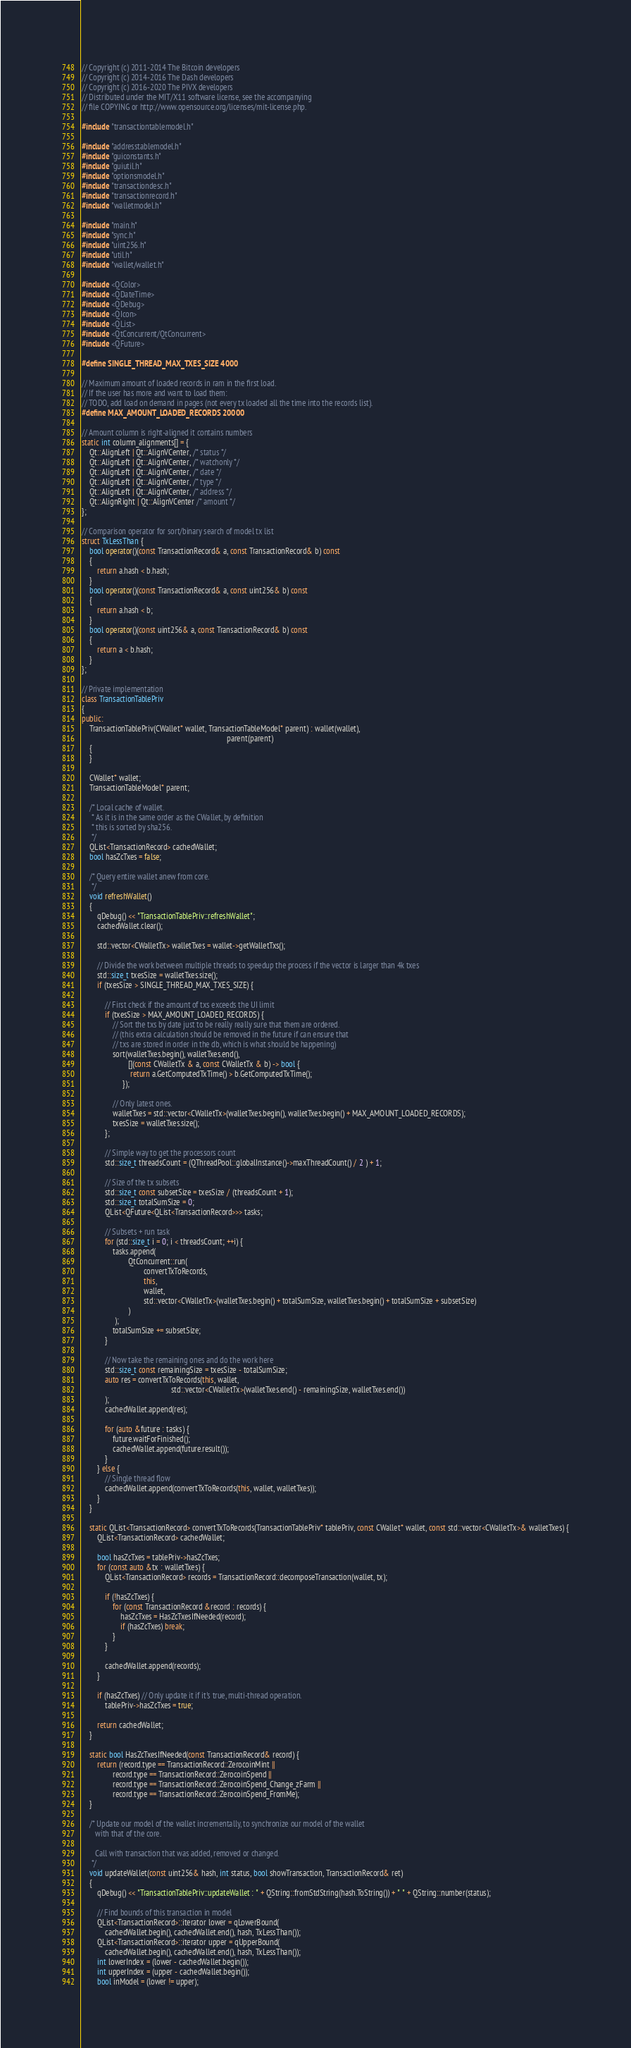<code> <loc_0><loc_0><loc_500><loc_500><_C++_>// Copyright (c) 2011-2014 The Bitcoin developers
// Copyright (c) 2014-2016 The Dash developers
// Copyright (c) 2016-2020 The PIVX developers
// Distributed under the MIT/X11 software license, see the accompanying
// file COPYING or http://www.opensource.org/licenses/mit-license.php.

#include "transactiontablemodel.h"

#include "addresstablemodel.h"
#include "guiconstants.h"
#include "guiutil.h"
#include "optionsmodel.h"
#include "transactiondesc.h"
#include "transactionrecord.h"
#include "walletmodel.h"

#include "main.h"
#include "sync.h"
#include "uint256.h"
#include "util.h"
#include "wallet/wallet.h"

#include <QColor>
#include <QDateTime>
#include <QDebug>
#include <QIcon>
#include <QList>
#include <QtConcurrent/QtConcurrent>
#include <QFuture>

#define SINGLE_THREAD_MAX_TXES_SIZE 4000

// Maximum amount of loaded records in ram in the first load.
// If the user has more and want to load them:
// TODO, add load on demand in pages (not every tx loaded all the time into the records list).
#define MAX_AMOUNT_LOADED_RECORDS 20000

// Amount column is right-aligned it contains numbers
static int column_alignments[] = {
    Qt::AlignLeft | Qt::AlignVCenter, /* status */
    Qt::AlignLeft | Qt::AlignVCenter, /* watchonly */
    Qt::AlignLeft | Qt::AlignVCenter, /* date */
    Qt::AlignLeft | Qt::AlignVCenter, /* type */
    Qt::AlignLeft | Qt::AlignVCenter, /* address */
    Qt::AlignRight | Qt::AlignVCenter /* amount */
};

// Comparison operator for sort/binary search of model tx list
struct TxLessThan {
    bool operator()(const TransactionRecord& a, const TransactionRecord& b) const
    {
        return a.hash < b.hash;
    }
    bool operator()(const TransactionRecord& a, const uint256& b) const
    {
        return a.hash < b;
    }
    bool operator()(const uint256& a, const TransactionRecord& b) const
    {
        return a < b.hash;
    }
};

// Private implementation
class TransactionTablePriv
{
public:
    TransactionTablePriv(CWallet* wallet, TransactionTableModel* parent) : wallet(wallet),
                                                                           parent(parent)
    {
    }

    CWallet* wallet;
    TransactionTableModel* parent;

    /* Local cache of wallet.
     * As it is in the same order as the CWallet, by definition
     * this is sorted by sha256.
     */
    QList<TransactionRecord> cachedWallet;
    bool hasZcTxes = false;

    /* Query entire wallet anew from core.
     */
    void refreshWallet()
    {
        qDebug() << "TransactionTablePriv::refreshWallet";
        cachedWallet.clear();

        std::vector<CWalletTx> walletTxes = wallet->getWalletTxs();

        // Divide the work between multiple threads to speedup the process if the vector is larger than 4k txes
        std::size_t txesSize = walletTxes.size();
        if (txesSize > SINGLE_THREAD_MAX_TXES_SIZE) {

            // First check if the amount of txs exceeds the UI limit
            if (txesSize > MAX_AMOUNT_LOADED_RECORDS) {
                // Sort the txs by date just to be really really sure that them are ordered.
                // (this extra calculation should be removed in the future if can ensure that
                // txs are stored in order in the db, which is what should be happening)
                sort(walletTxes.begin(), walletTxes.end(),
                        [](const CWalletTx & a, const CWalletTx & b) -> bool {
                         return a.GetComputedTxTime() > b.GetComputedTxTime();
                     });

                // Only latest ones.
                walletTxes = std::vector<CWalletTx>(walletTxes.begin(), walletTxes.begin() + MAX_AMOUNT_LOADED_RECORDS);
                txesSize = walletTxes.size();
            };

            // Simple way to get the processors count
            std::size_t threadsCount = (QThreadPool::globalInstance()->maxThreadCount() / 2 ) + 1;

            // Size of the tx subsets
            std::size_t const subsetSize = txesSize / (threadsCount + 1);
            std::size_t totalSumSize = 0;
            QList<QFuture<QList<TransactionRecord>>> tasks;

            // Subsets + run task
            for (std::size_t i = 0; i < threadsCount; ++i) {
                tasks.append(
                        QtConcurrent::run(
                                convertTxToRecords,
                                this,
                                wallet,
                                std::vector<CWalletTx>(walletTxes.begin() + totalSumSize, walletTxes.begin() + totalSumSize + subsetSize)
                        )
                 );
                totalSumSize += subsetSize;
            }

            // Now take the remaining ones and do the work here
            std::size_t const remainingSize = txesSize - totalSumSize;
            auto res = convertTxToRecords(this, wallet,
                                              std::vector<CWalletTx>(walletTxes.end() - remainingSize, walletTxes.end())
            );
            cachedWallet.append(res);

            for (auto &future : tasks) {
                future.waitForFinished();
                cachedWallet.append(future.result());
            }
        } else {
            // Single thread flow
            cachedWallet.append(convertTxToRecords(this, wallet, walletTxes));
        }
    }

    static QList<TransactionRecord> convertTxToRecords(TransactionTablePriv* tablePriv, const CWallet* wallet, const std::vector<CWalletTx>& walletTxes) {
        QList<TransactionRecord> cachedWallet;

        bool hasZcTxes = tablePriv->hasZcTxes;
        for (const auto &tx : walletTxes) {
            QList<TransactionRecord> records = TransactionRecord::decomposeTransaction(wallet, tx);

            if (!hasZcTxes) {
                for (const TransactionRecord &record : records) {
                    hasZcTxes = HasZcTxesIfNeeded(record);
                    if (hasZcTxes) break;
                }
            }

            cachedWallet.append(records);
        }

        if (hasZcTxes) // Only update it if it's true, multi-thread operation.
            tablePriv->hasZcTxes = true;

        return cachedWallet;
    }

    static bool HasZcTxesIfNeeded(const TransactionRecord& record) {
        return (record.type == TransactionRecord::ZerocoinMint ||
                record.type == TransactionRecord::ZerocoinSpend ||
                record.type == TransactionRecord::ZerocoinSpend_Change_zFarm ||
                record.type == TransactionRecord::ZerocoinSpend_FromMe);
    }

    /* Update our model of the wallet incrementally, to synchronize our model of the wallet
       with that of the core.

       Call with transaction that was added, removed or changed.
     */
    void updateWallet(const uint256& hash, int status, bool showTransaction, TransactionRecord& ret)
    {
        qDebug() << "TransactionTablePriv::updateWallet : " + QString::fromStdString(hash.ToString()) + " " + QString::number(status);

        // Find bounds of this transaction in model
        QList<TransactionRecord>::iterator lower = qLowerBound(
            cachedWallet.begin(), cachedWallet.end(), hash, TxLessThan());
        QList<TransactionRecord>::iterator upper = qUpperBound(
            cachedWallet.begin(), cachedWallet.end(), hash, TxLessThan());
        int lowerIndex = (lower - cachedWallet.begin());
        int upperIndex = (upper - cachedWallet.begin());
        bool inModel = (lower != upper);
</code> 